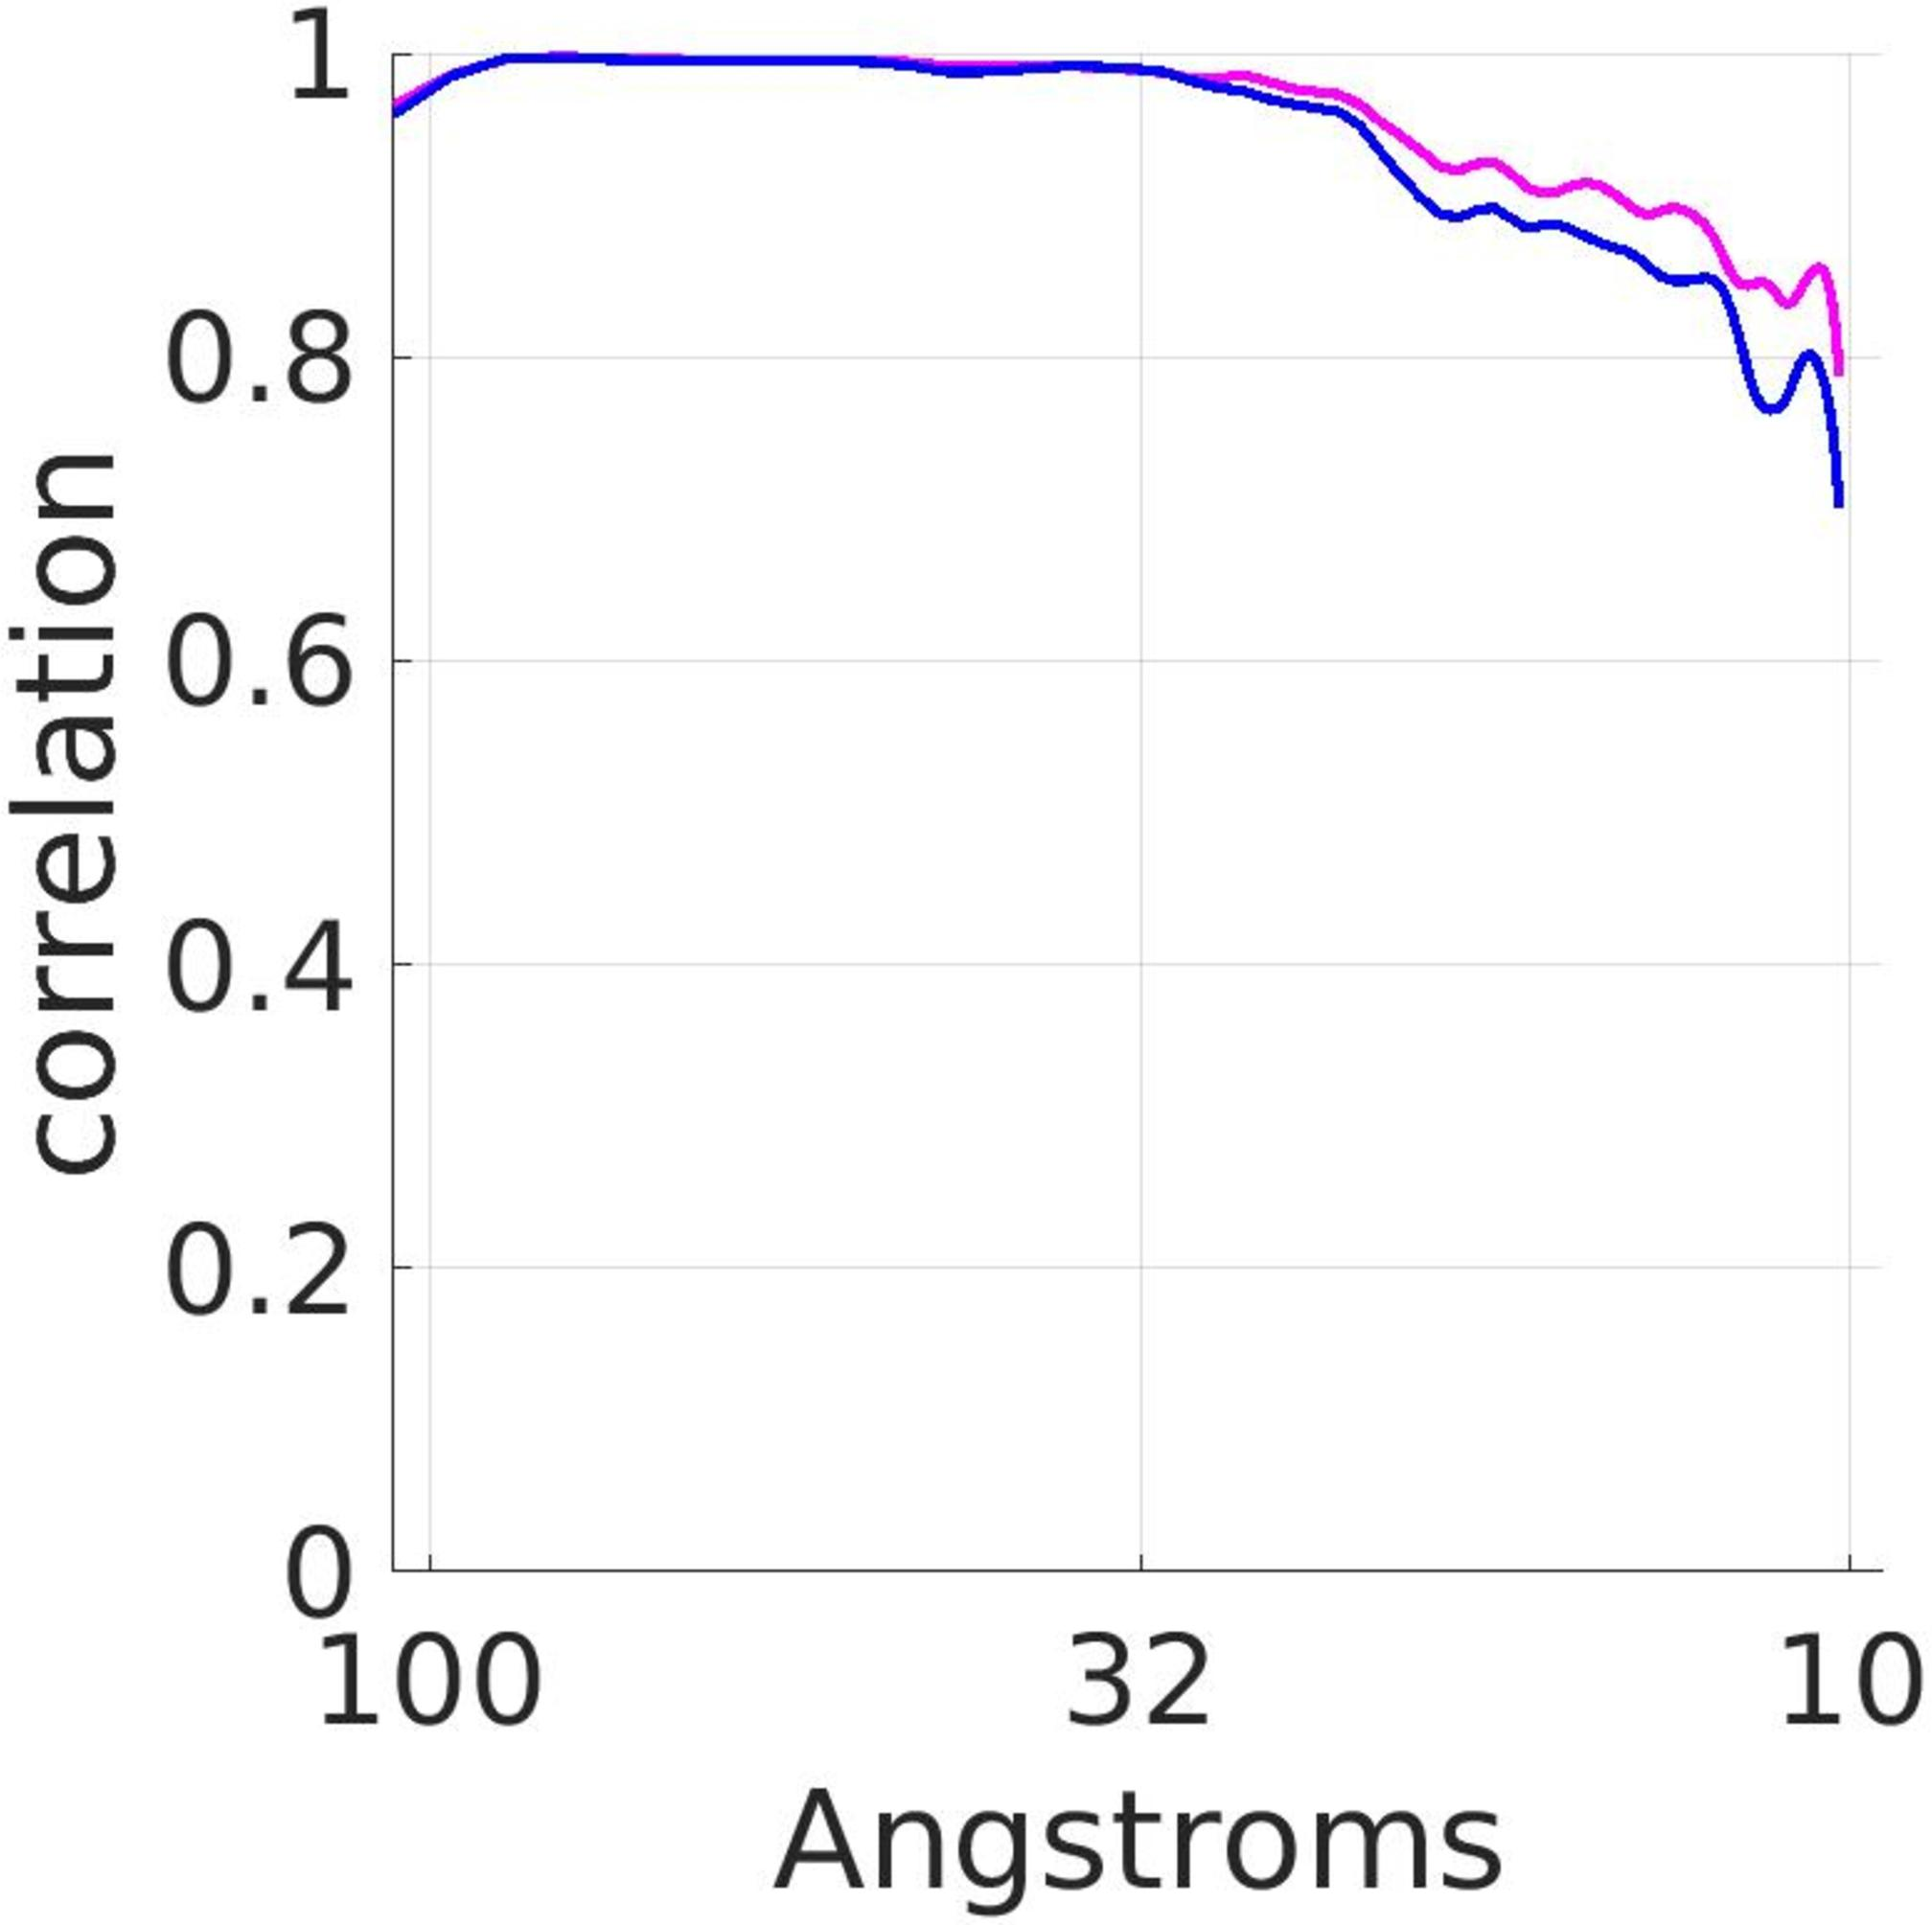If the pattern observed in the graph continues beyond the range shown, what would be the expected correlation value at 200 angstroms? Approximately 0.2 Approximately 0.5 Approximately 0.8 The pattern cannot be reliably extended to 200 angstroms. The graph only shows data up to 100 angstroms, and there's a noticeable variability in correlation values as distance increases. Without further data, it is not scientifically sound to extrapolate the pattern to 200 angstroms, hence the correct answer is that the pattern cannot be reliably extended to that distance. Therefore, the correct answer is D. 